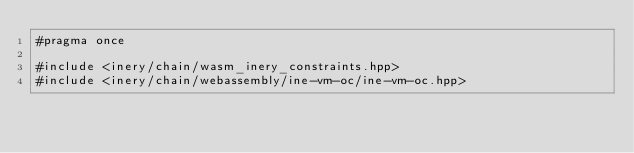Convert code to text. <code><loc_0><loc_0><loc_500><loc_500><_C++_>#pragma once

#include <inery/chain/wasm_inery_constraints.hpp>
#include <inery/chain/webassembly/ine-vm-oc/ine-vm-oc.hpp></code> 